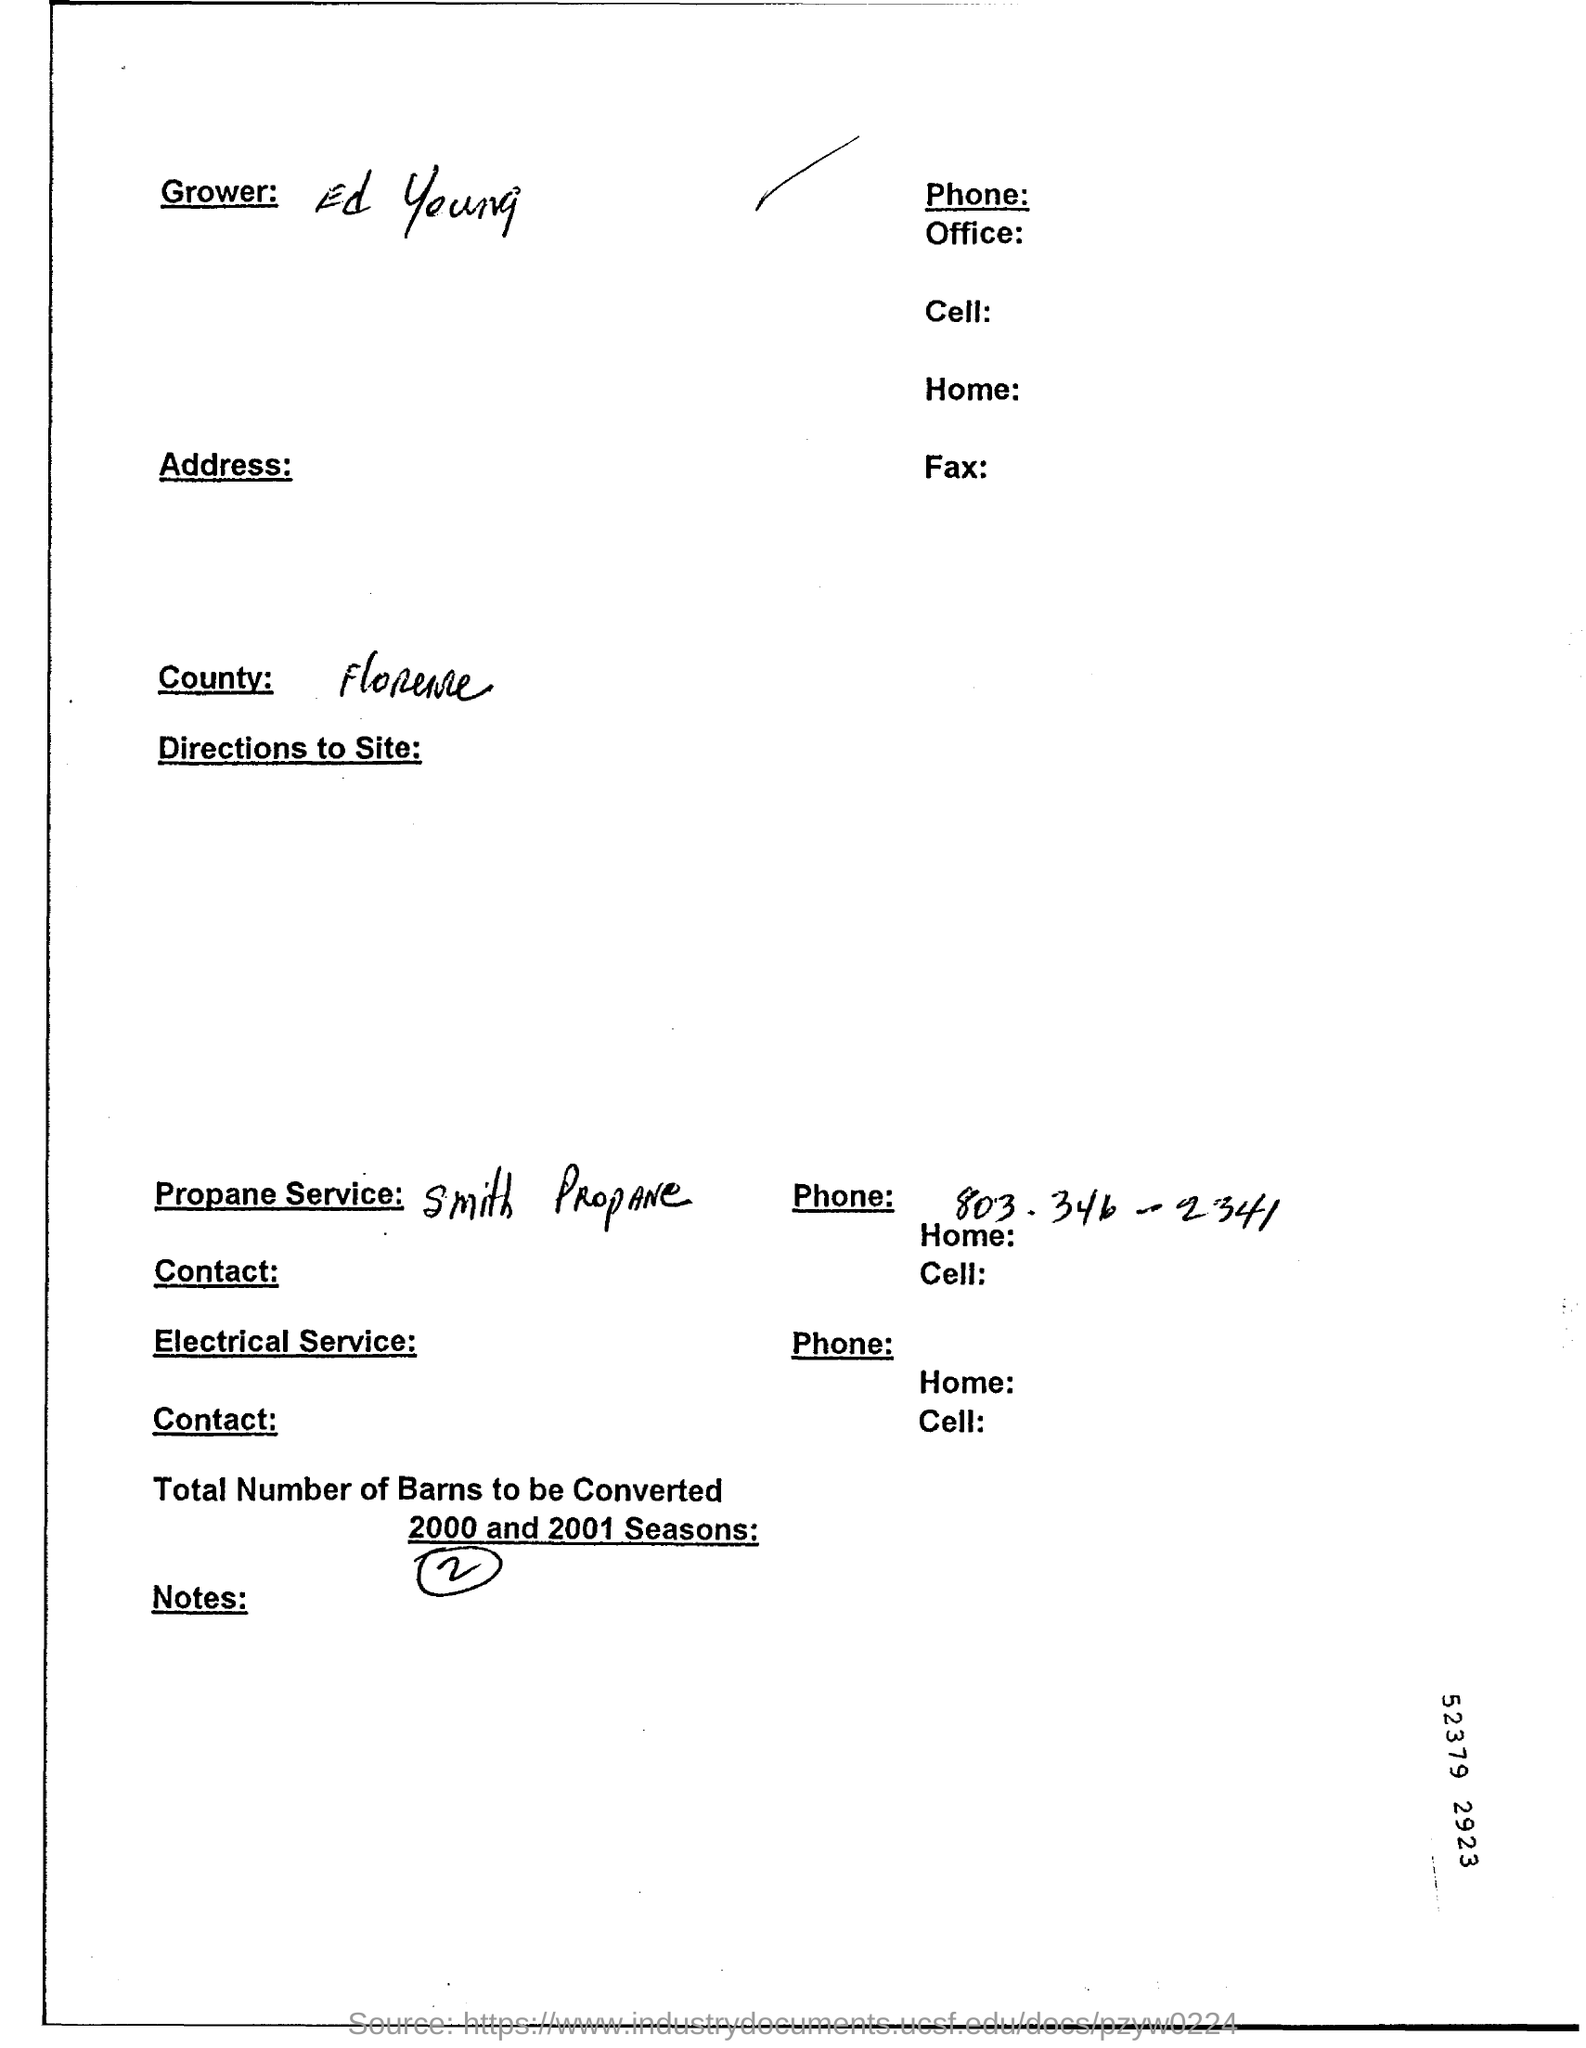Mention a couple of crucial points in this snapshot. The grower is Ed Young. 